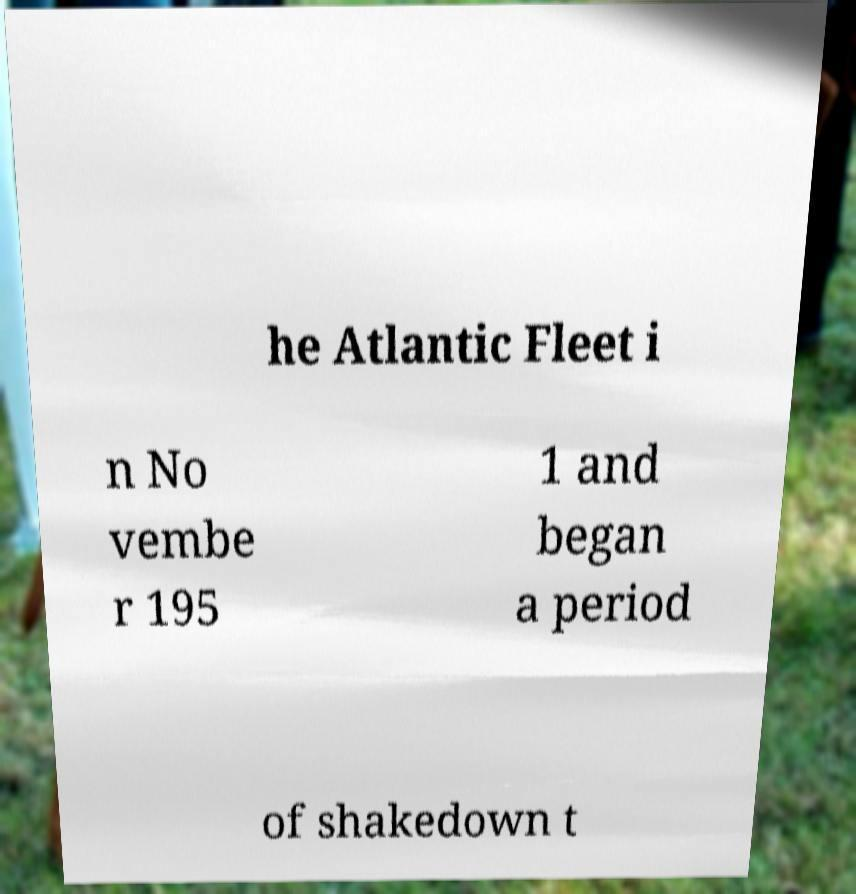Could you extract and type out the text from this image? he Atlantic Fleet i n No vembe r 195 1 and began a period of shakedown t 